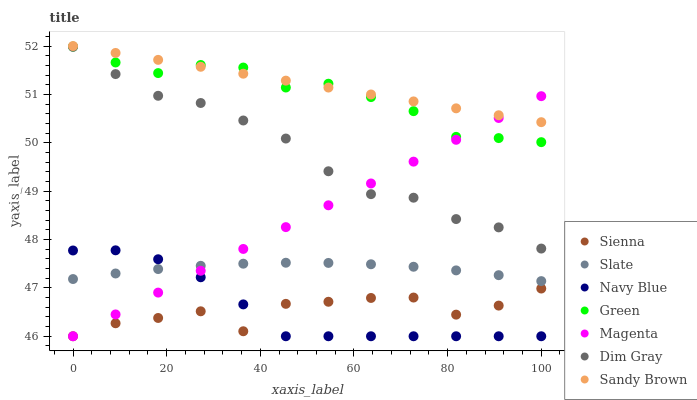Does Sienna have the minimum area under the curve?
Answer yes or no. Yes. Does Sandy Brown have the maximum area under the curve?
Answer yes or no. Yes. Does Navy Blue have the minimum area under the curve?
Answer yes or no. No. Does Navy Blue have the maximum area under the curve?
Answer yes or no. No. Is Sandy Brown the smoothest?
Answer yes or no. Yes. Is Sienna the roughest?
Answer yes or no. Yes. Is Navy Blue the smoothest?
Answer yes or no. No. Is Navy Blue the roughest?
Answer yes or no. No. Does Navy Blue have the lowest value?
Answer yes or no. Yes. Does Slate have the lowest value?
Answer yes or no. No. Does Sandy Brown have the highest value?
Answer yes or no. Yes. Does Navy Blue have the highest value?
Answer yes or no. No. Is Navy Blue less than Green?
Answer yes or no. Yes. Is Green greater than Navy Blue?
Answer yes or no. Yes. Does Navy Blue intersect Slate?
Answer yes or no. Yes. Is Navy Blue less than Slate?
Answer yes or no. No. Is Navy Blue greater than Slate?
Answer yes or no. No. Does Navy Blue intersect Green?
Answer yes or no. No. 